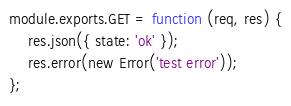Convert code to text. <code><loc_0><loc_0><loc_500><loc_500><_JavaScript_>module.exports.GET = function (req, res) {
    res.json({ state: 'ok' });
    res.error(new Error('test error'));
};
</code> 